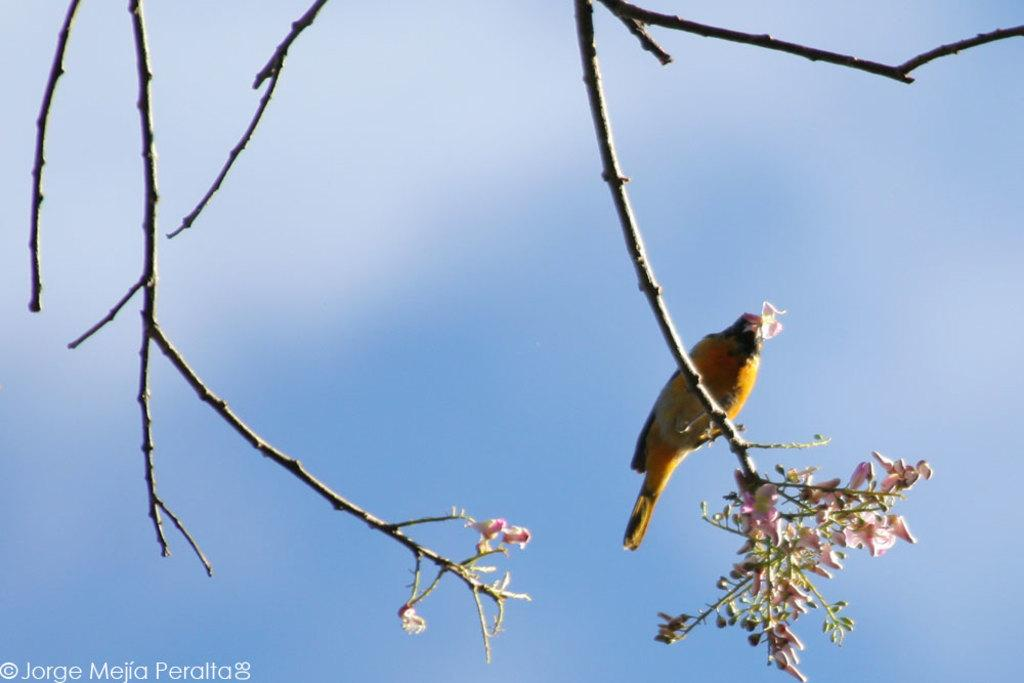What type of animal can be seen in the image? There is a bird in the image. Where is the bird located in the image? The bird is standing on the stems of a tree. What can be seen in the background of the image? There is sky visible in the background of the image. What is present in the sky? Clouds are present in the sky. What type of crib can be seen in the image? There is no crib present in the image; it features a bird standing on the stems of a tree. How does the bird crack the tree stems in the image? The bird does not crack the tree stems in the image; it is simply standing on them. 